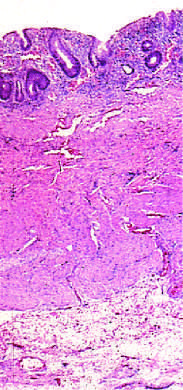what shows that disease is limited to the mucosa?
Answer the question using a single word or phrase. The full-thickness histologic section 